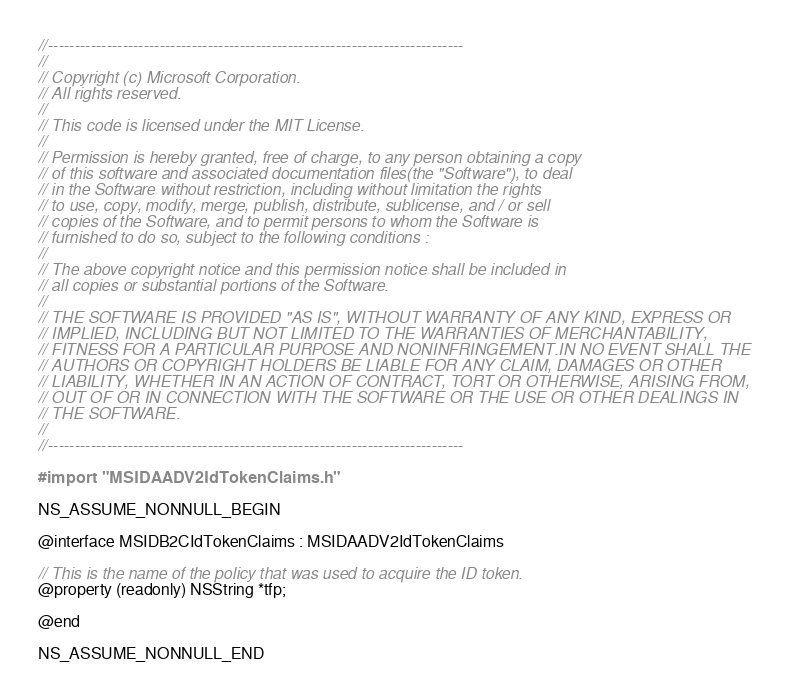Convert code to text. <code><loc_0><loc_0><loc_500><loc_500><_C_>//------------------------------------------------------------------------------
//
// Copyright (c) Microsoft Corporation.
// All rights reserved.
//
// This code is licensed under the MIT License.
//
// Permission is hereby granted, free of charge, to any person obtaining a copy
// of this software and associated documentation files(the "Software"), to deal
// in the Software without restriction, including without limitation the rights
// to use, copy, modify, merge, publish, distribute, sublicense, and / or sell
// copies of the Software, and to permit persons to whom the Software is
// furnished to do so, subject to the following conditions :
//
// The above copyright notice and this permission notice shall be included in
// all copies or substantial portions of the Software.
//
// THE SOFTWARE IS PROVIDED "AS IS", WITHOUT WARRANTY OF ANY KIND, EXPRESS OR
// IMPLIED, INCLUDING BUT NOT LIMITED TO THE WARRANTIES OF MERCHANTABILITY,
// FITNESS FOR A PARTICULAR PURPOSE AND NONINFRINGEMENT.IN NO EVENT SHALL THE
// AUTHORS OR COPYRIGHT HOLDERS BE LIABLE FOR ANY CLAIM, DAMAGES OR OTHER
// LIABILITY, WHETHER IN AN ACTION OF CONTRACT, TORT OR OTHERWISE, ARISING FROM,
// OUT OF OR IN CONNECTION WITH THE SOFTWARE OR THE USE OR OTHER DEALINGS IN
// THE SOFTWARE.
//
//------------------------------------------------------------------------------

#import "MSIDAADV2IdTokenClaims.h"

NS_ASSUME_NONNULL_BEGIN

@interface MSIDB2CIdTokenClaims : MSIDAADV2IdTokenClaims

// This is the name of the policy that was used to acquire the ID token.
@property (readonly) NSString *tfp;

@end

NS_ASSUME_NONNULL_END
</code> 